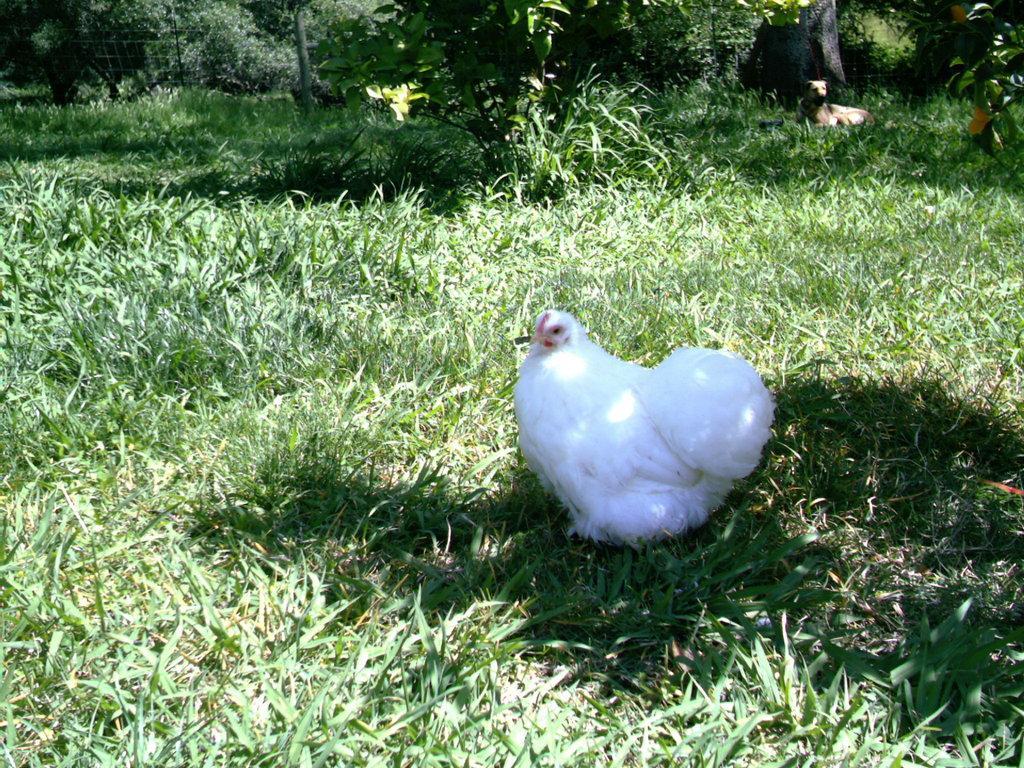Please provide a concise description of this image. In this image I can see some grass on the ground which is green in color and a hen which is white, red and black in color. In the background I can see few trees and a dog which is brown in color. 